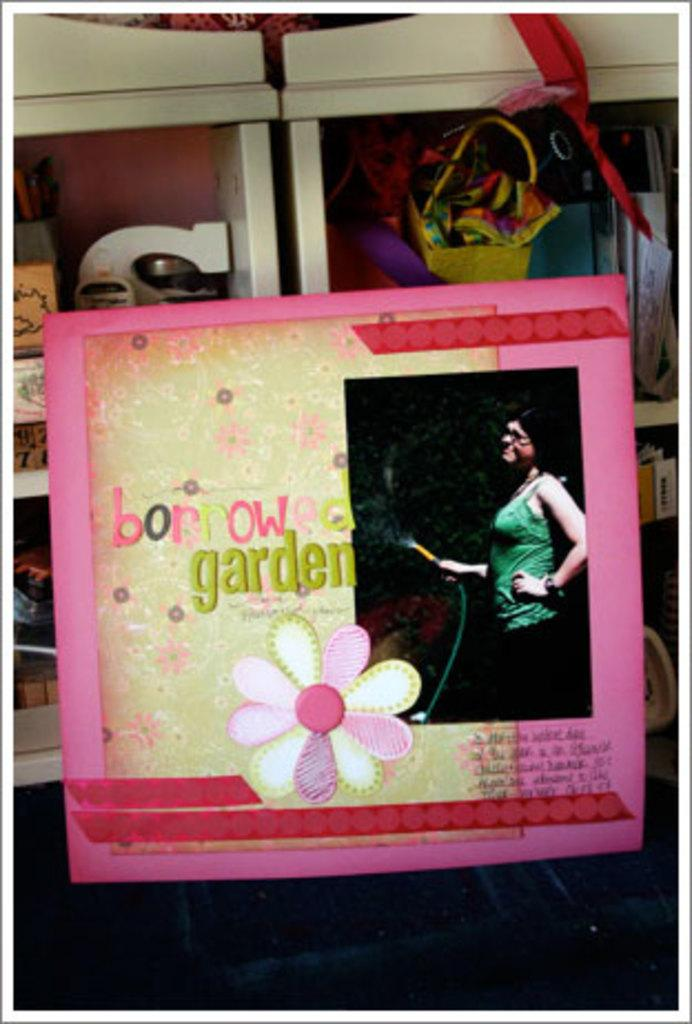What is the main subject of the image? The main subject of the image is a frame. Can you describe the design on the frame? The frame has a design of a flower. What can be seen in the background of the image? There are shelves with other things visible in the background. Can you tell me how many donkeys are standing next to the frame in the image? There are no donkeys present in the image; it only features a frame with a flower design and shelves in the background. 